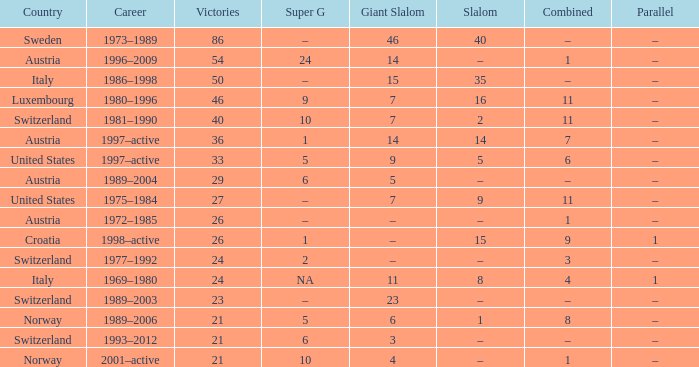What Career has a Super G of 5, and a Combined of 6? 1997–active. 